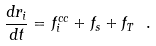<formula> <loc_0><loc_0><loc_500><loc_500>\frac { d { r } _ { i } } { d t } = { f } _ { i } ^ { c c } + { f } _ { s } + { f } _ { T } \ .</formula> 